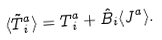<formula> <loc_0><loc_0><loc_500><loc_500>\langle \tilde { T } ^ { a } _ { \, i } \rangle = T ^ { a } _ { \, i } + \hat { B } _ { i } \langle J ^ { a } \rangle .</formula> 